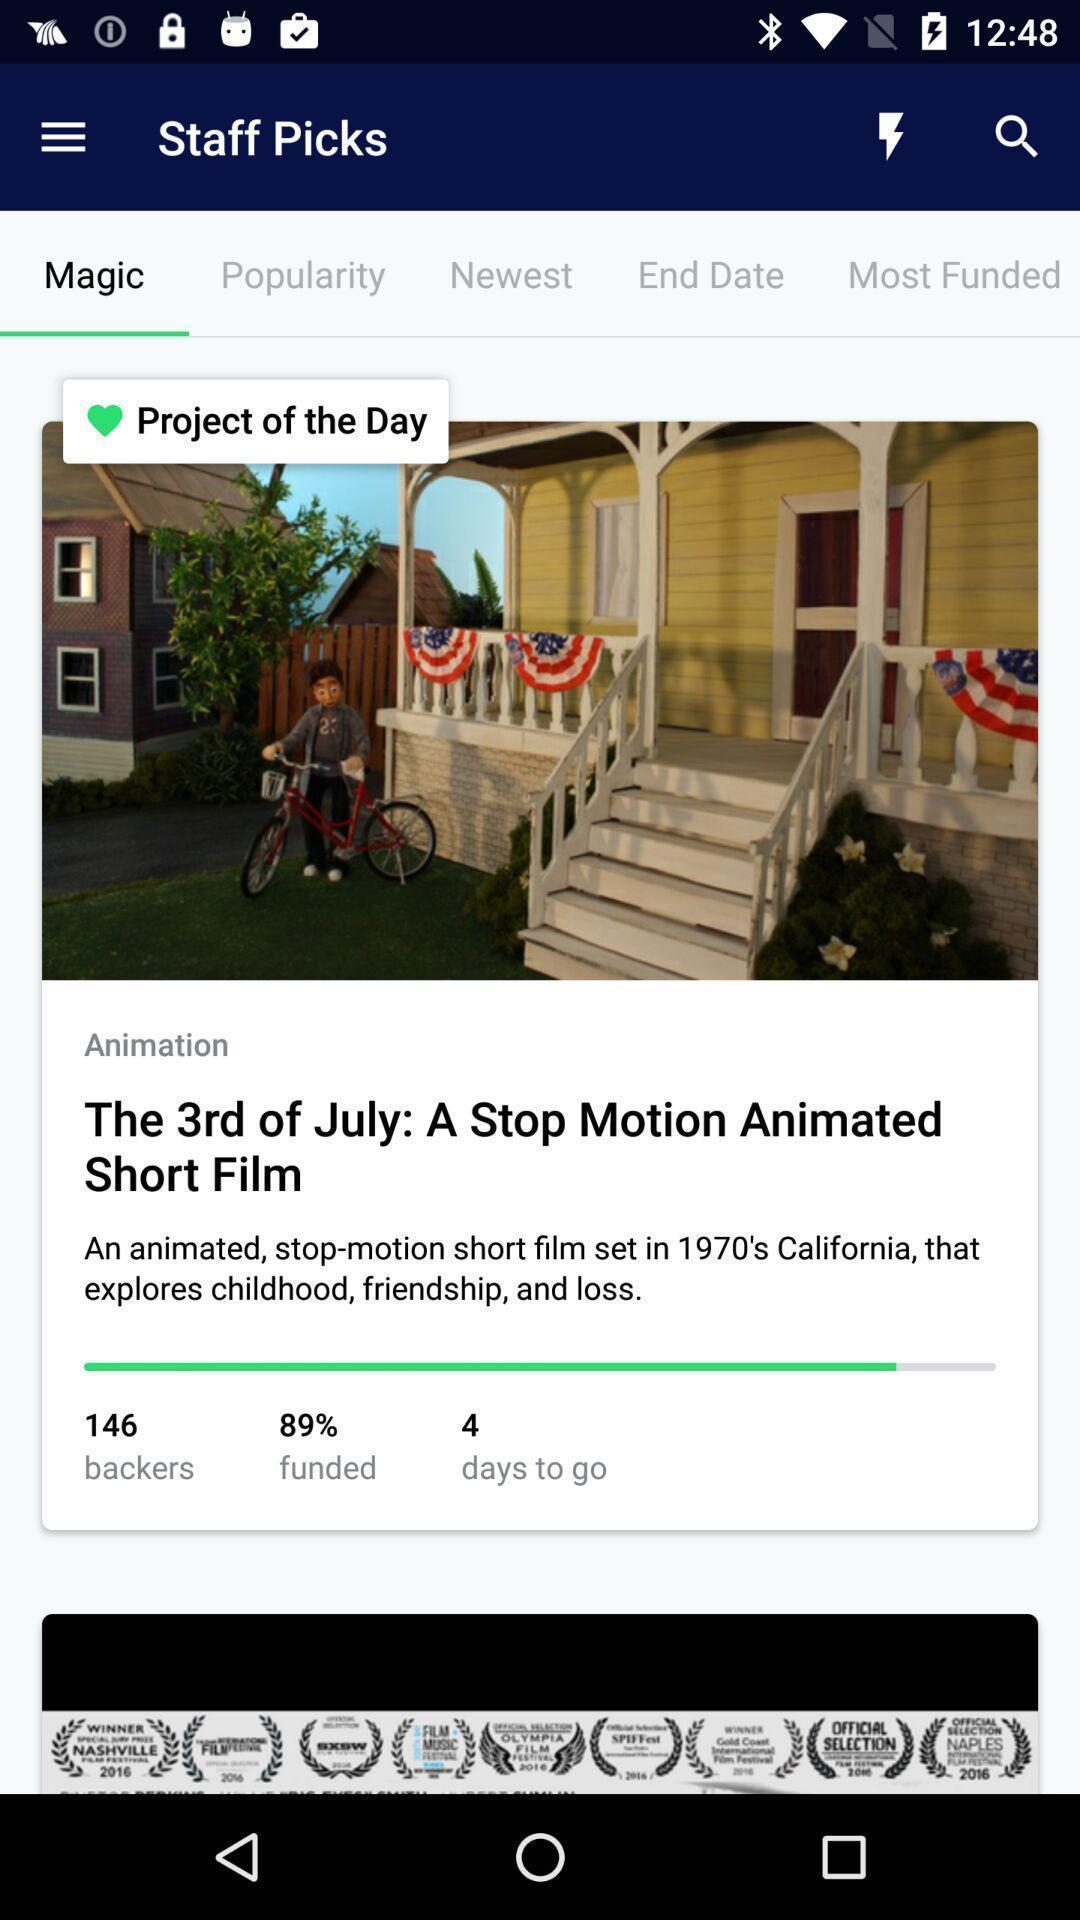What is the overall content of this screenshot? Page displaying with animated short film and details of it. 